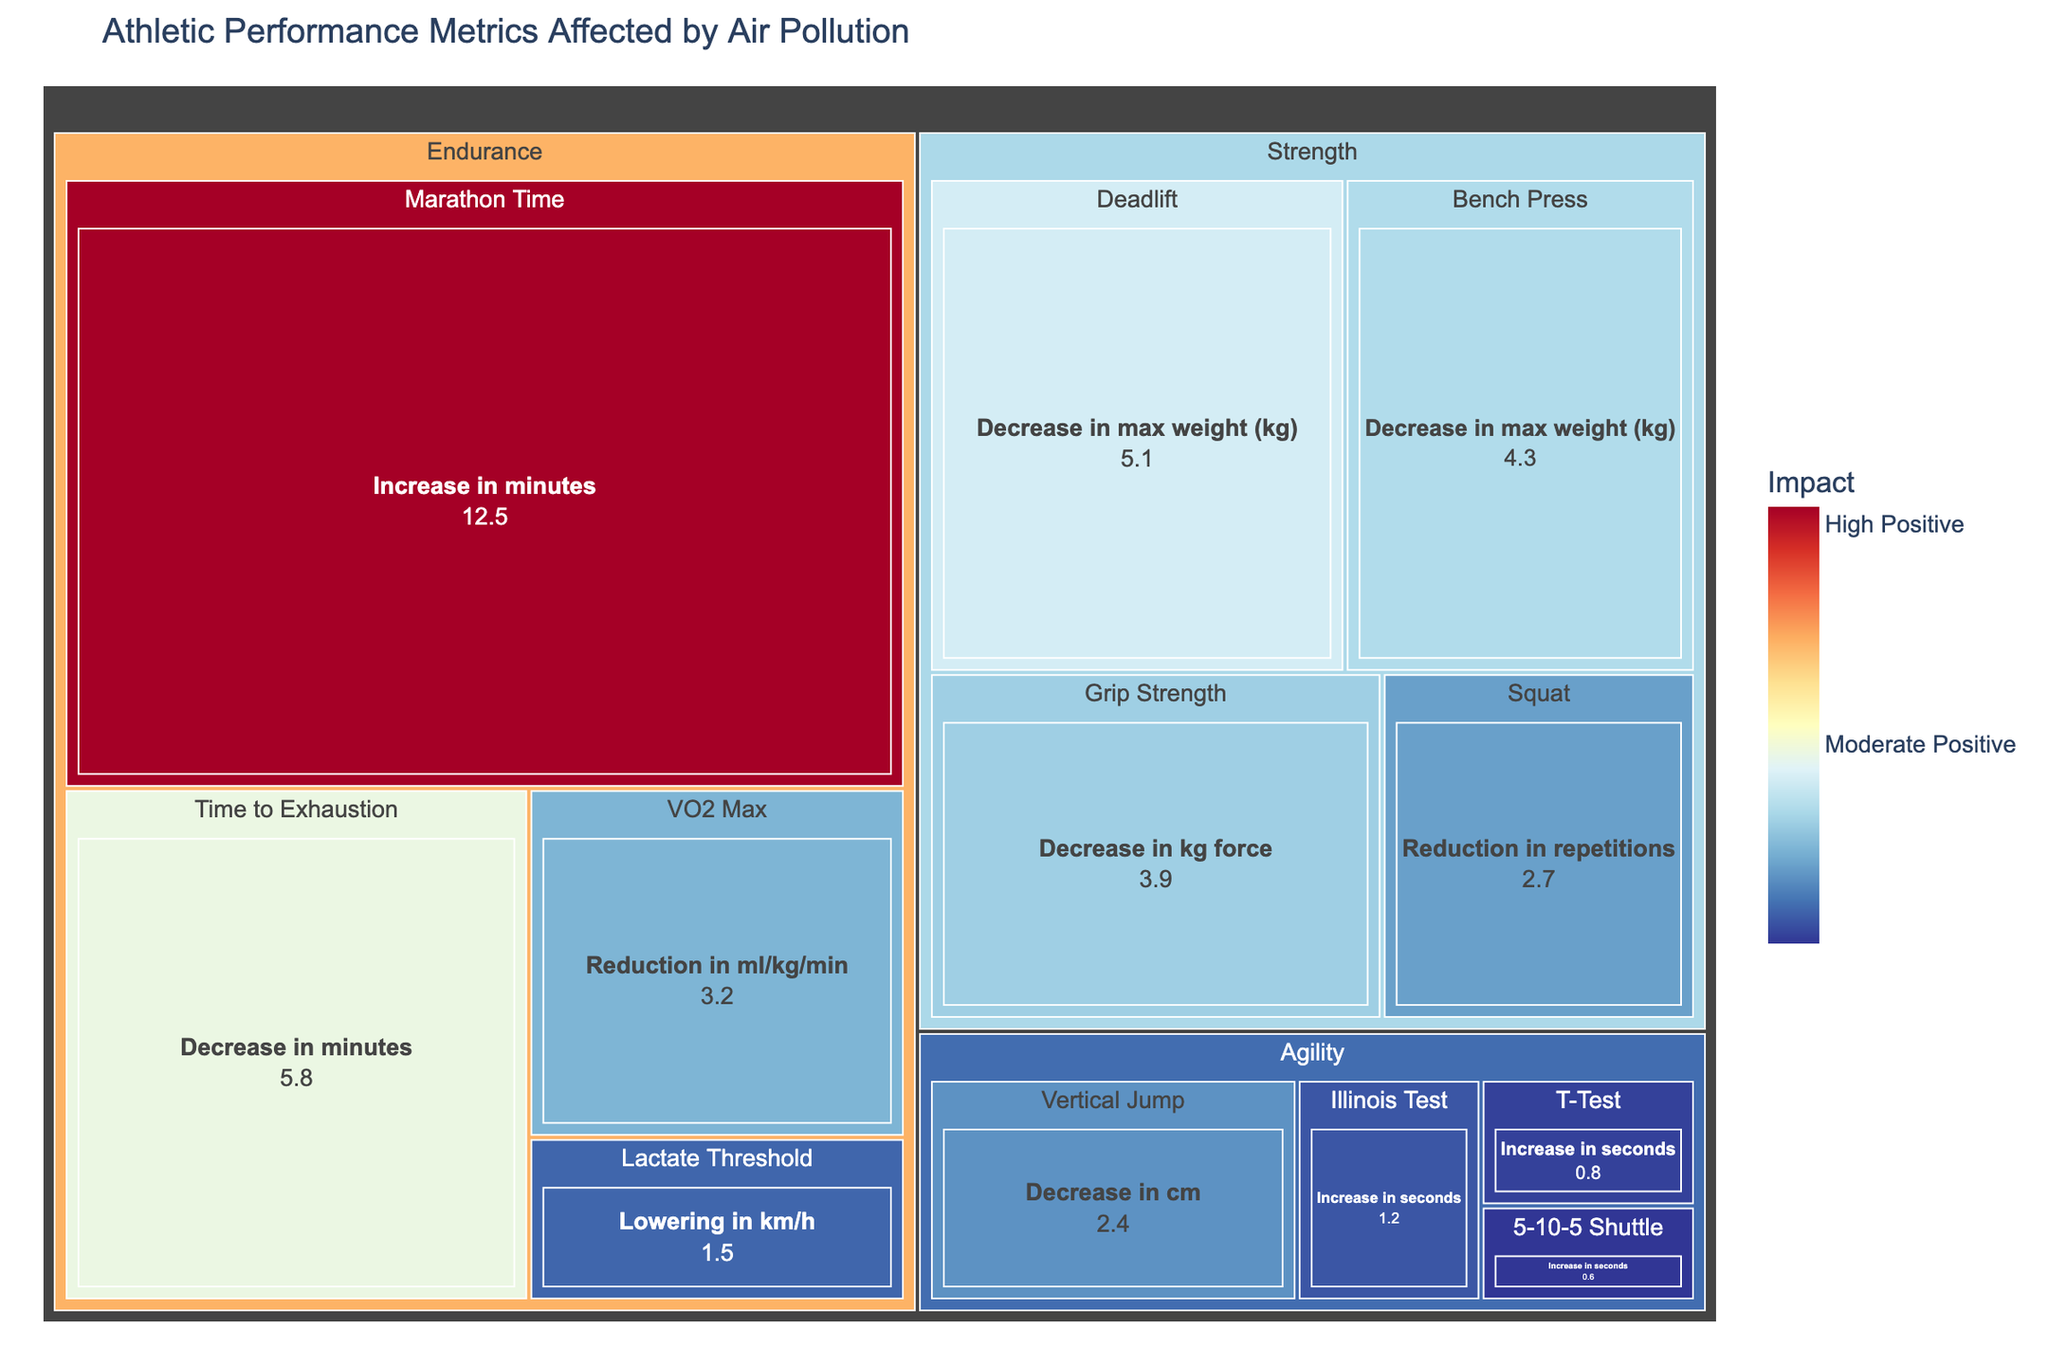How is the performance metric "Time to Exhaustion" affected by air pollution? The treemap shows that "Time to Exhaustion" falls under the "Endurance" category and has a decrease of 5.8 minutes due to air pollution.
Answer: Decreased by 5.8 minutes What is the metric with the largest positive impact in the "Strength" category? Reviewing all metrics under "Strength," the one with the largest value is "Deadlift" with a decrease of 5.1 kg. However, since negative impacts are coded with positive size values, it confirms there are no positive impacts in the Strength category in the figure.
Answer: None Sum up the numeric values associated with the "Agility" category. The values for the Agility metrics are 0.8 (T-Test), 1.2 (Illinois Test), 0.6 (5-10-5 Shuttle), and 2.4 (Vertical Jump). Summing these values: 0.8 + 1.2 + 0.6 + 2.4 = 5.0.
Answer: 5.0 Which "Endurance" metric is least affected by air pollution? In the "Endurance" category, the metric with the smallest numerical value of air pollution impact is "Lactate Threshold" with a lowering of 1.5 km/h.
Answer: Lactate Threshold Compare the impact on "Bench Press" and "Grip Strength." Which one is more affected? "Bench Press" has a decrease in max weight of 4.3 kg, while "Grip Strength" has a decrease in kg force of 3.9 kg. Therefore, "Bench Press" is more affected.
Answer: Bench Press Identify the category with the highest increase due to air pollution. The "Endurance" category has an increase in marathon time of 12.5 minutes, which is the highest increase among all metrics.
Answer: Endurance Find the average effect of air pollution on the "Strength" category. The Strength category includes these metrics: Bench Press (-4.3 kg), Squat (-2.7 reps), Deadlift (-5.1 kg), and Grip Strength (-3.9 kg). Sum these values: 4.3 + 2.7 + 5.1 + 3.9 = 16.0. Average is 16.0 / 4 = 4.0.
Answer: 4.0 Which "Agility" metric experiences the smallest impact? In the Agility category, the metric with the smallest numerical value is "5-10-5 Shuttle" with an increase of 0.6 seconds.
Answer: 5-10-5 Shuttle What are the subcategories under the "Endurance" category? The subcategories listed in "Endurance" are VO2 Max, Time to Exhaustion, Lactate Threshold, and Marathon Time.
Answer: VO2 Max, Time to Exhaustion, Lactate Threshold, Marathon Time 